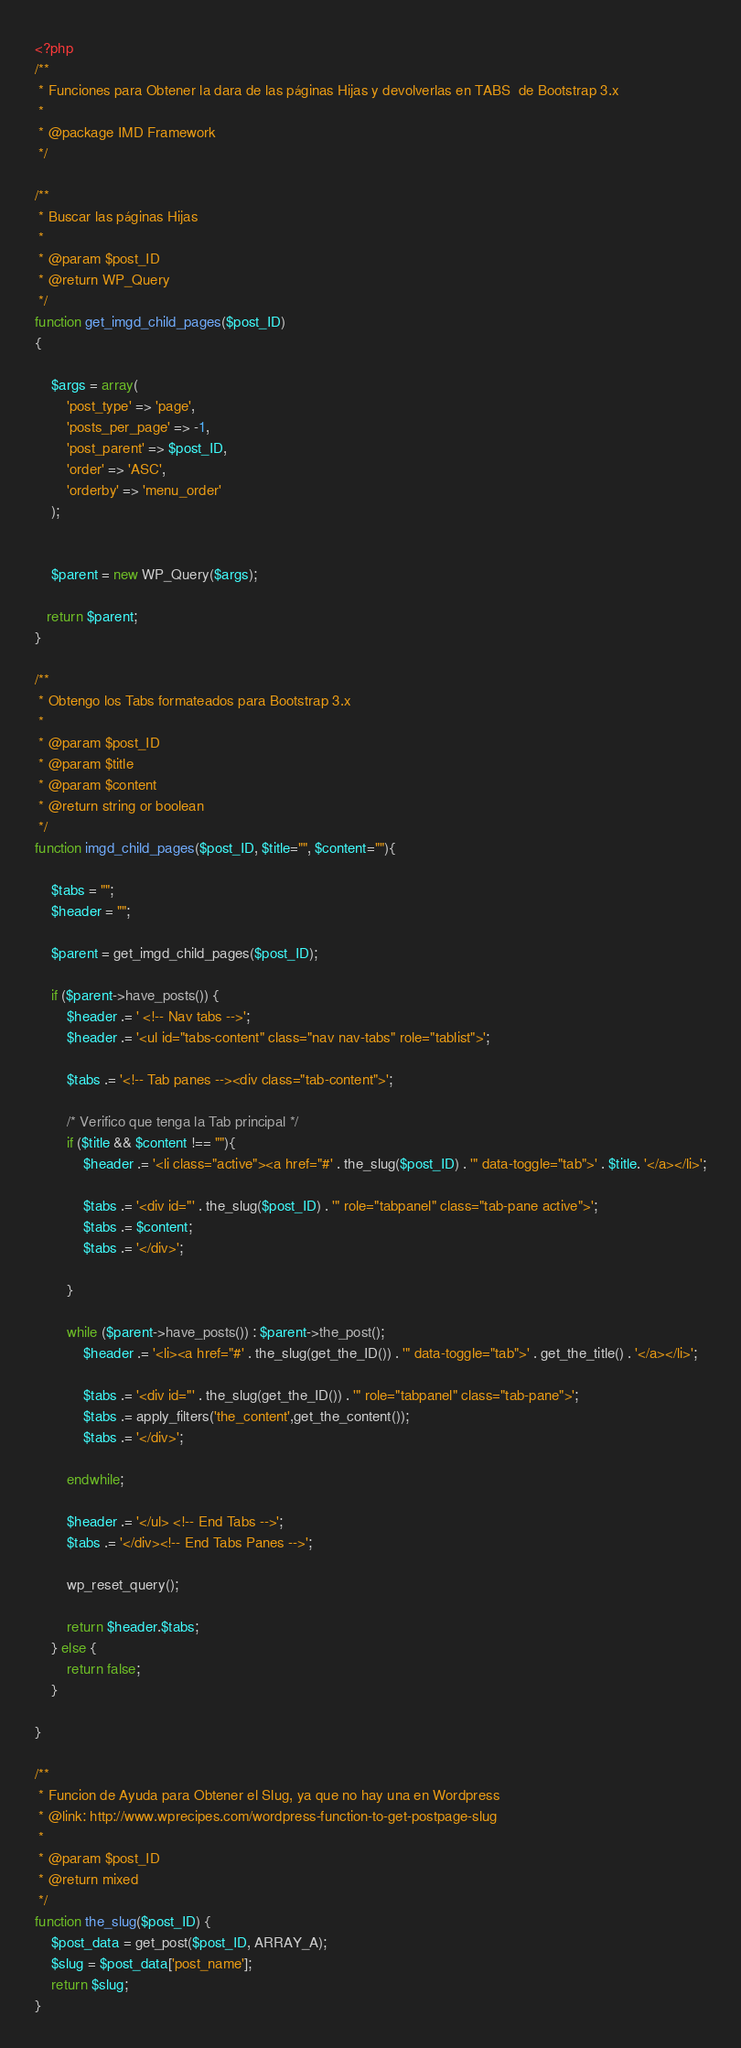Convert code to text. <code><loc_0><loc_0><loc_500><loc_500><_PHP_><?php
/**
 * Funciones para Obtener la dara de las páginas Hijas y devolverlas en TABS  de Bootstrap 3.x
 *
 * @package IMD Framework
 */

/**
 * Buscar las páginas Hijas
 *
 * @param $post_ID
 * @return WP_Query
 */
function get_imgd_child_pages($post_ID)
{

    $args = array(
        'post_type' => 'page',
        'posts_per_page' => -1,
        'post_parent' => $post_ID,
        'order' => 'ASC',
        'orderby' => 'menu_order'
    );


    $parent = new WP_Query($args);

   return $parent;
}

/**
 * Obtengo los Tabs formateados para Bootstrap 3.x
 *
 * @param $post_ID
 * @param $title
 * @param $content
 * @return string or boolean
 */
function imgd_child_pages($post_ID, $title="", $content=""){

    $tabs = "";
    $header = "";

    $parent = get_imgd_child_pages($post_ID);

    if ($parent->have_posts()) {
        $header .= ' <!-- Nav tabs -->';
        $header .= '<ul id="tabs-content" class="nav nav-tabs" role="tablist">';

        $tabs .= '<!-- Tab panes --><div class="tab-content">';

        /* Verifico que tenga la Tab principal */
        if ($title && $content !== ""){
            $header .= '<li class="active"><a href="#' . the_slug($post_ID) . '" data-toggle="tab">' . $title. '</a></li>';

            $tabs .= '<div id="' . the_slug($post_ID) . '" role="tabpanel" class="tab-pane active">';
            $tabs .= $content;
            $tabs .= '</div>';

        }

        while ($parent->have_posts()) : $parent->the_post();
            $header .= '<li><a href="#' . the_slug(get_the_ID()) . '" data-toggle="tab">' . get_the_title() . '</a></li>';

            $tabs .= '<div id="' . the_slug(get_the_ID()) . '" role="tabpanel" class="tab-pane">';
            $tabs .= apply_filters('the_content',get_the_content());
            $tabs .= '</div>';

        endwhile;

        $header .= '</ul> <!-- End Tabs -->';
        $tabs .= '</div><!-- End Tabs Panes -->';

        wp_reset_query();

        return $header.$tabs;
    } else {
        return false;
    }

}

/**
 * Funcion de Ayuda para Obtener el Slug, ya que no hay una en Wordpress
 * @link: http://www.wprecipes.com/wordpress-function-to-get-postpage-slug
 *
 * @param $post_ID
 * @return mixed
 */
function the_slug($post_ID) {
    $post_data = get_post($post_ID, ARRAY_A);
    $slug = $post_data['post_name'];
    return $slug;
}
</code> 